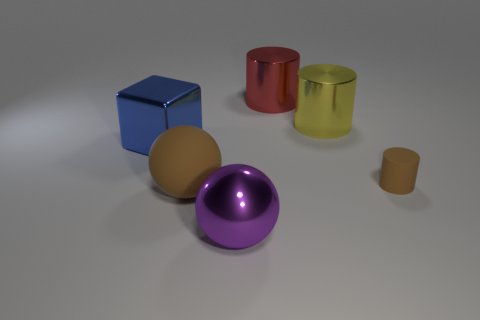Is the large red object the same shape as the yellow object?
Provide a short and direct response. Yes. Are there any brown objects on the right side of the big shiny thing in front of the brown cylinder that is to the right of the rubber sphere?
Give a very brief answer. Yes. How many other things are the same color as the cube?
Your answer should be compact. 0. There is a ball that is right of the large brown matte ball; is it the same size as the brown object in front of the brown matte cylinder?
Make the answer very short. Yes. Is the number of brown matte objects that are in front of the brown ball the same as the number of metal balls that are in front of the tiny brown matte cylinder?
Your response must be concise. No. Does the metallic sphere have the same size as the rubber thing that is on the right side of the big purple metallic sphere?
Make the answer very short. No. What is the sphere that is behind the metallic object that is in front of the large blue metallic object made of?
Provide a short and direct response. Rubber. Is the number of red objects right of the matte cylinder the same as the number of large yellow matte balls?
Provide a succinct answer. Yes. There is a thing that is left of the purple shiny thing and in front of the block; how big is it?
Provide a succinct answer. Large. The big ball that is right of the brown matte object in front of the tiny brown object is what color?
Provide a short and direct response. Purple. 